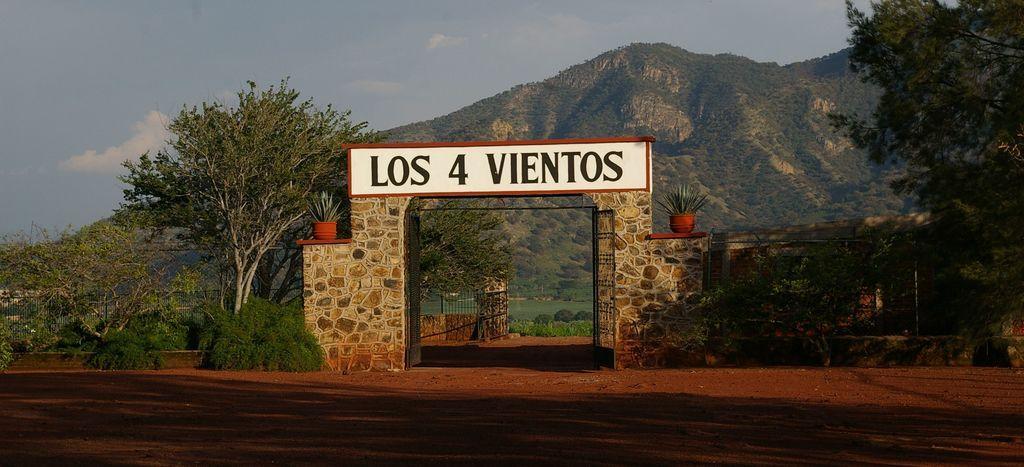In one or two sentences, can you explain what this image depicts? In the foreground of this picture, there is an entrance gate and on a board written as "LOS 4 VIENTOS" and there are plants, trees, wall, mountains, railing, sky and the cloud. 